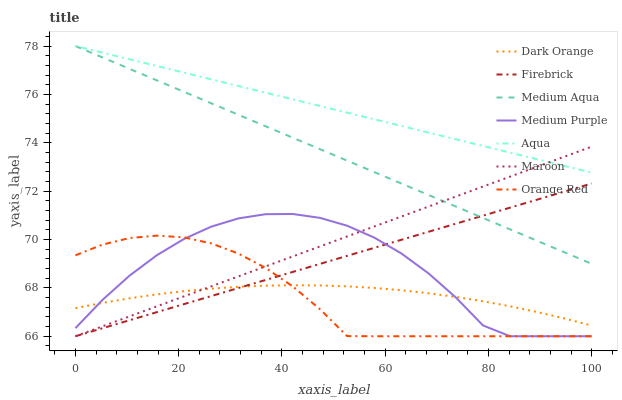Does Orange Red have the minimum area under the curve?
Answer yes or no. Yes. Does Aqua have the maximum area under the curve?
Answer yes or no. Yes. Does Firebrick have the minimum area under the curve?
Answer yes or no. No. Does Firebrick have the maximum area under the curve?
Answer yes or no. No. Is Aqua the smoothest?
Answer yes or no. Yes. Is Medium Purple the roughest?
Answer yes or no. Yes. Is Firebrick the smoothest?
Answer yes or no. No. Is Firebrick the roughest?
Answer yes or no. No. Does Firebrick have the lowest value?
Answer yes or no. Yes. Does Aqua have the lowest value?
Answer yes or no. No. Does Medium Aqua have the highest value?
Answer yes or no. Yes. Does Firebrick have the highest value?
Answer yes or no. No. Is Orange Red less than Aqua?
Answer yes or no. Yes. Is Aqua greater than Orange Red?
Answer yes or no. Yes. Does Orange Red intersect Maroon?
Answer yes or no. Yes. Is Orange Red less than Maroon?
Answer yes or no. No. Is Orange Red greater than Maroon?
Answer yes or no. No. Does Orange Red intersect Aqua?
Answer yes or no. No. 